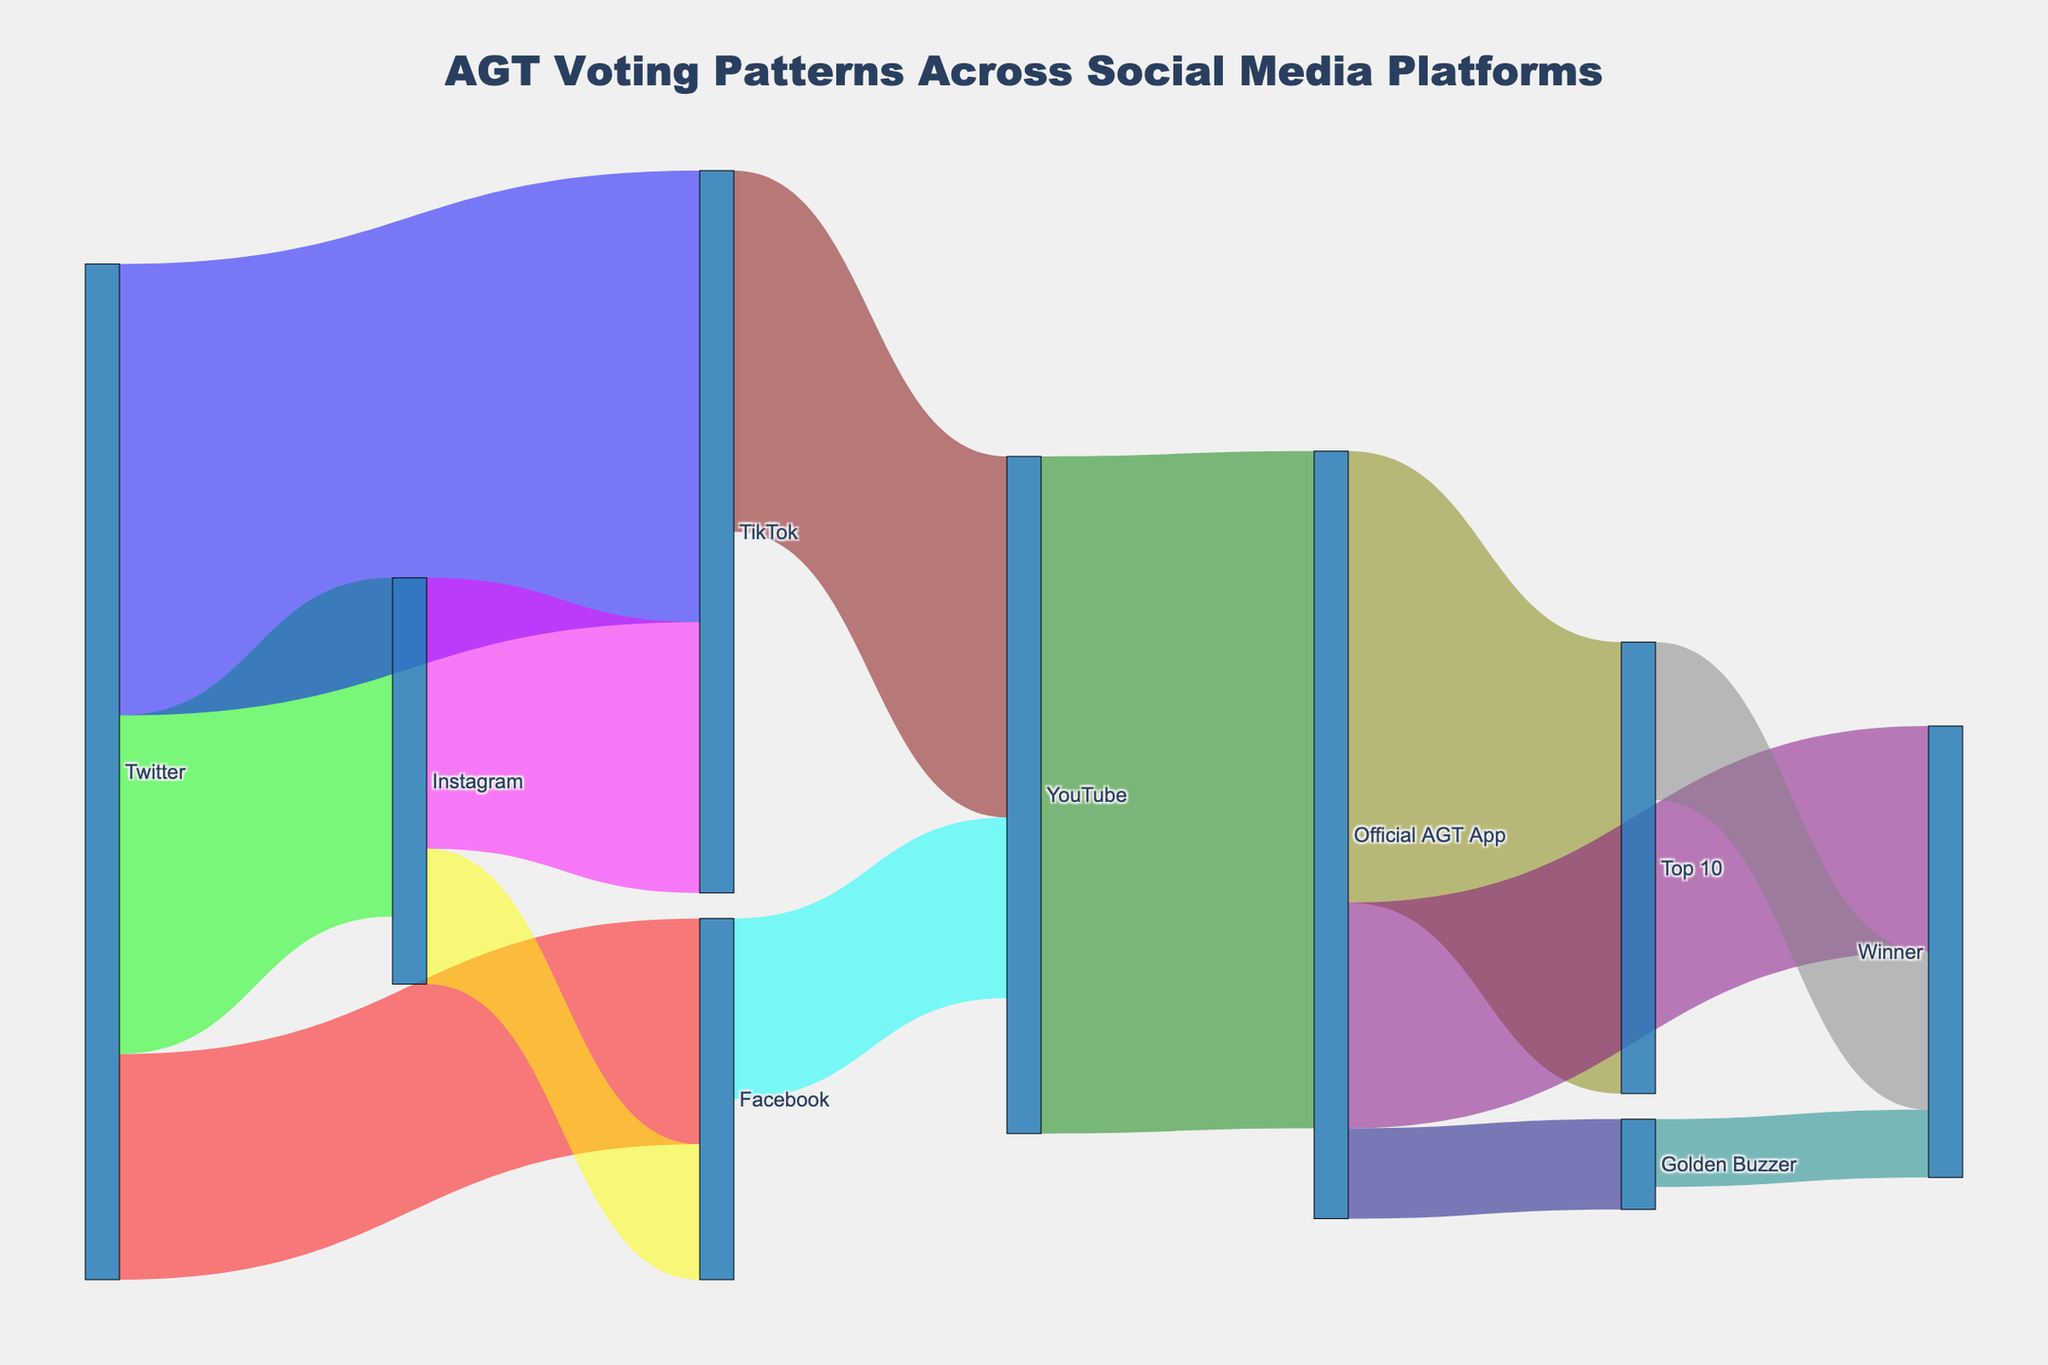what is the title of the Sankey diagram? The title is prominently displayed at the top of the diagram. It provides an overview of what the data represents.
Answer: AGT Voting Patterns Across Social Media Platforms Which platform received the highest number of votes starting from Twitter? By following the paths originating from Twitter, we count the votes leading to each linked platform. Twitter to TikTok has the highest number of votes at 100,000.
Answer: TikTok How many total votes flowed into the Official AGT App from other platforms? Follow the paths leading into the Official AGT App and add the respective vote numbers: 150,000 votes from YouTube.
Answer: 150,000 Which final voting stage received the most votes? By looking at the final nodes on the right and summing their incoming votes, the 'Top 10' received 100,000 votes, 'Winner' received 35,000 from Top 10, 50,000 from Official AGT App, and 15,000 from Golden Buzzer. Summing these up gives a larger number; hence 'Winner' received the most votes in total.
Answer: Winner How do votes from Instagram split among other platforms? By following paths from Instagram, we see it splits into Facebook (30,000 votes) and TikTok (60,000 votes).
Answer: Facebook and TikTok Compare the total votes TikTok received directly and indirectly. Which one is higher? Directly, TikTok received votes from Twitter (100,000) and Instagram (60,000) for a total of 160,000. Indirectly, we see TikTok does not receive indirect votes.
Answer: Directly What is the combined total of votes flowing into the 'Winner' from all sources? Sum the votes flowing into 'Winner' from 'Golden Buzzer' (15,000), through 'Official AGT App' (50,000), and from 'Top 10' (35,000). Hence, 15,000 + 50,000 + 35,000 = 100,000.
Answer: 100,000 Which pathway had the least number of votes from the Official AGT App? Look at the paths originating from the Official AGT App node. The pathway to 'Golden Buzzer' has the least votes at 20,000.
Answer: Golden Buzzer 